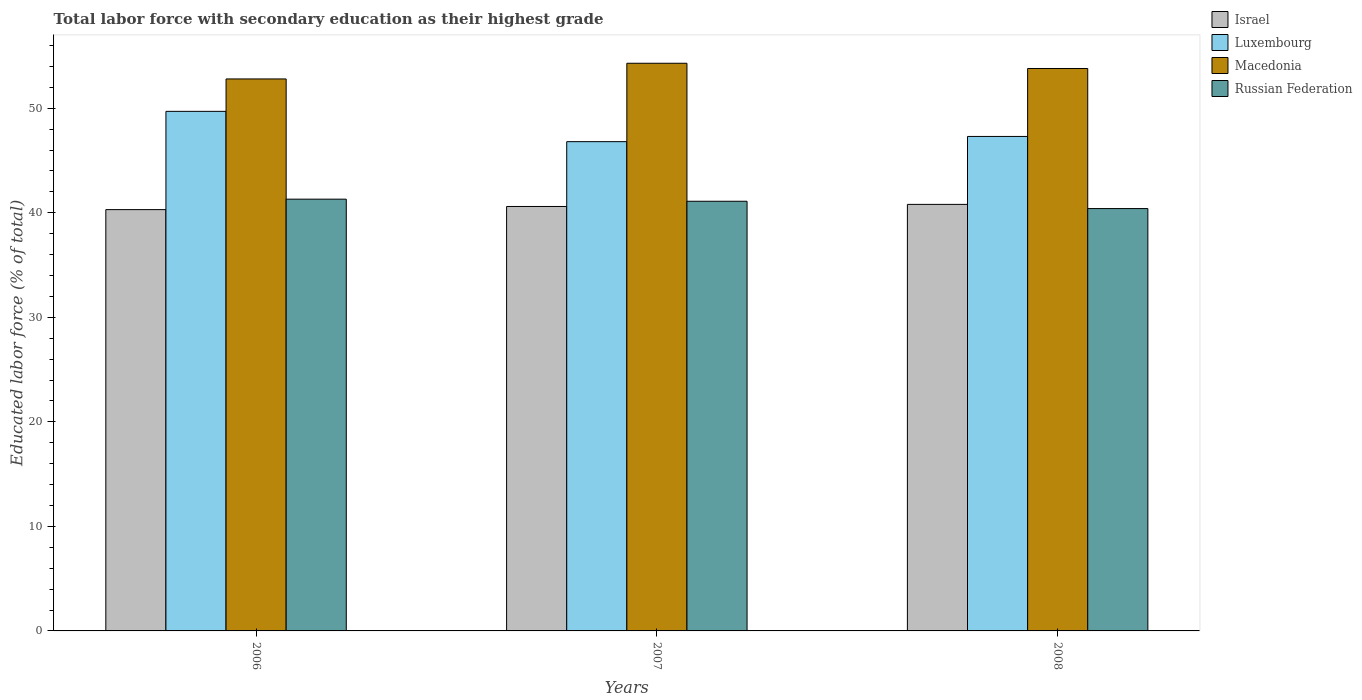Are the number of bars per tick equal to the number of legend labels?
Your response must be concise. Yes. Are the number of bars on each tick of the X-axis equal?
Offer a very short reply. Yes. How many bars are there on the 2nd tick from the left?
Your answer should be very brief. 4. How many bars are there on the 3rd tick from the right?
Your response must be concise. 4. What is the percentage of total labor force with primary education in Macedonia in 2006?
Keep it short and to the point. 52.8. Across all years, what is the maximum percentage of total labor force with primary education in Israel?
Offer a very short reply. 40.8. Across all years, what is the minimum percentage of total labor force with primary education in Luxembourg?
Your answer should be compact. 46.8. In which year was the percentage of total labor force with primary education in Luxembourg maximum?
Offer a terse response. 2006. What is the total percentage of total labor force with primary education in Israel in the graph?
Offer a terse response. 121.7. What is the average percentage of total labor force with primary education in Israel per year?
Your response must be concise. 40.57. In the year 2006, what is the difference between the percentage of total labor force with primary education in Macedonia and percentage of total labor force with primary education in Luxembourg?
Make the answer very short. 3.1. In how many years, is the percentage of total labor force with primary education in Israel greater than 44 %?
Give a very brief answer. 0. What is the ratio of the percentage of total labor force with primary education in Russian Federation in 2007 to that in 2008?
Offer a terse response. 1.02. What is the difference between the highest and the lowest percentage of total labor force with primary education in Israel?
Ensure brevity in your answer.  0.5. Is the sum of the percentage of total labor force with primary education in Macedonia in 2006 and 2007 greater than the maximum percentage of total labor force with primary education in Israel across all years?
Ensure brevity in your answer.  Yes. What does the 2nd bar from the left in 2006 represents?
Keep it short and to the point. Luxembourg. What does the 1st bar from the right in 2007 represents?
Provide a succinct answer. Russian Federation. Is it the case that in every year, the sum of the percentage of total labor force with primary education in Israel and percentage of total labor force with primary education in Macedonia is greater than the percentage of total labor force with primary education in Luxembourg?
Keep it short and to the point. Yes. How many bars are there?
Give a very brief answer. 12. Are all the bars in the graph horizontal?
Offer a very short reply. No. What is the difference between two consecutive major ticks on the Y-axis?
Your response must be concise. 10. Where does the legend appear in the graph?
Offer a terse response. Top right. How are the legend labels stacked?
Your response must be concise. Vertical. What is the title of the graph?
Offer a very short reply. Total labor force with secondary education as their highest grade. What is the label or title of the X-axis?
Your answer should be compact. Years. What is the label or title of the Y-axis?
Keep it short and to the point. Educated labor force (% of total). What is the Educated labor force (% of total) of Israel in 2006?
Make the answer very short. 40.3. What is the Educated labor force (% of total) of Luxembourg in 2006?
Keep it short and to the point. 49.7. What is the Educated labor force (% of total) of Macedonia in 2006?
Your answer should be very brief. 52.8. What is the Educated labor force (% of total) in Russian Federation in 2006?
Offer a terse response. 41.3. What is the Educated labor force (% of total) in Israel in 2007?
Keep it short and to the point. 40.6. What is the Educated labor force (% of total) in Luxembourg in 2007?
Your response must be concise. 46.8. What is the Educated labor force (% of total) in Macedonia in 2007?
Provide a short and direct response. 54.3. What is the Educated labor force (% of total) in Russian Federation in 2007?
Offer a terse response. 41.1. What is the Educated labor force (% of total) in Israel in 2008?
Offer a terse response. 40.8. What is the Educated labor force (% of total) of Luxembourg in 2008?
Ensure brevity in your answer.  47.3. What is the Educated labor force (% of total) in Macedonia in 2008?
Your response must be concise. 53.8. What is the Educated labor force (% of total) in Russian Federation in 2008?
Offer a terse response. 40.4. Across all years, what is the maximum Educated labor force (% of total) of Israel?
Give a very brief answer. 40.8. Across all years, what is the maximum Educated labor force (% of total) in Luxembourg?
Provide a short and direct response. 49.7. Across all years, what is the maximum Educated labor force (% of total) in Macedonia?
Your answer should be very brief. 54.3. Across all years, what is the maximum Educated labor force (% of total) in Russian Federation?
Offer a very short reply. 41.3. Across all years, what is the minimum Educated labor force (% of total) in Israel?
Keep it short and to the point. 40.3. Across all years, what is the minimum Educated labor force (% of total) in Luxembourg?
Your answer should be very brief. 46.8. Across all years, what is the minimum Educated labor force (% of total) of Macedonia?
Give a very brief answer. 52.8. Across all years, what is the minimum Educated labor force (% of total) of Russian Federation?
Your answer should be compact. 40.4. What is the total Educated labor force (% of total) in Israel in the graph?
Ensure brevity in your answer.  121.7. What is the total Educated labor force (% of total) in Luxembourg in the graph?
Keep it short and to the point. 143.8. What is the total Educated labor force (% of total) of Macedonia in the graph?
Provide a succinct answer. 160.9. What is the total Educated labor force (% of total) of Russian Federation in the graph?
Offer a terse response. 122.8. What is the difference between the Educated labor force (% of total) of Israel in 2006 and that in 2007?
Provide a short and direct response. -0.3. What is the difference between the Educated labor force (% of total) of Russian Federation in 2006 and that in 2007?
Your answer should be very brief. 0.2. What is the difference between the Educated labor force (% of total) of Israel in 2006 and that in 2008?
Ensure brevity in your answer.  -0.5. What is the difference between the Educated labor force (% of total) of Luxembourg in 2006 and that in 2008?
Offer a terse response. 2.4. What is the difference between the Educated labor force (% of total) of Israel in 2007 and that in 2008?
Your answer should be compact. -0.2. What is the difference between the Educated labor force (% of total) of Luxembourg in 2007 and that in 2008?
Your answer should be compact. -0.5. What is the difference between the Educated labor force (% of total) of Macedonia in 2007 and that in 2008?
Keep it short and to the point. 0.5. What is the difference between the Educated labor force (% of total) of Russian Federation in 2007 and that in 2008?
Keep it short and to the point. 0.7. What is the difference between the Educated labor force (% of total) in Israel in 2006 and the Educated labor force (% of total) in Luxembourg in 2007?
Ensure brevity in your answer.  -6.5. What is the difference between the Educated labor force (% of total) in Israel in 2006 and the Educated labor force (% of total) in Macedonia in 2007?
Your response must be concise. -14. What is the difference between the Educated labor force (% of total) of Israel in 2006 and the Educated labor force (% of total) of Russian Federation in 2007?
Provide a succinct answer. -0.8. What is the difference between the Educated labor force (% of total) in Luxembourg in 2006 and the Educated labor force (% of total) in Macedonia in 2007?
Provide a succinct answer. -4.6. What is the difference between the Educated labor force (% of total) of Macedonia in 2006 and the Educated labor force (% of total) of Russian Federation in 2007?
Your answer should be very brief. 11.7. What is the difference between the Educated labor force (% of total) of Israel in 2006 and the Educated labor force (% of total) of Russian Federation in 2008?
Ensure brevity in your answer.  -0.1. What is the difference between the Educated labor force (% of total) in Luxembourg in 2006 and the Educated labor force (% of total) in Macedonia in 2008?
Your answer should be very brief. -4.1. What is the difference between the Educated labor force (% of total) in Luxembourg in 2006 and the Educated labor force (% of total) in Russian Federation in 2008?
Provide a succinct answer. 9.3. What is the difference between the Educated labor force (% of total) of Macedonia in 2006 and the Educated labor force (% of total) of Russian Federation in 2008?
Offer a terse response. 12.4. What is the difference between the Educated labor force (% of total) in Israel in 2007 and the Educated labor force (% of total) in Russian Federation in 2008?
Make the answer very short. 0.2. What is the difference between the Educated labor force (% of total) in Luxembourg in 2007 and the Educated labor force (% of total) in Macedonia in 2008?
Make the answer very short. -7. What is the difference between the Educated labor force (% of total) in Macedonia in 2007 and the Educated labor force (% of total) in Russian Federation in 2008?
Offer a very short reply. 13.9. What is the average Educated labor force (% of total) of Israel per year?
Give a very brief answer. 40.57. What is the average Educated labor force (% of total) in Luxembourg per year?
Give a very brief answer. 47.93. What is the average Educated labor force (% of total) of Macedonia per year?
Offer a terse response. 53.63. What is the average Educated labor force (% of total) of Russian Federation per year?
Offer a terse response. 40.93. In the year 2006, what is the difference between the Educated labor force (% of total) in Israel and Educated labor force (% of total) in Luxembourg?
Your answer should be compact. -9.4. In the year 2006, what is the difference between the Educated labor force (% of total) of Israel and Educated labor force (% of total) of Macedonia?
Offer a very short reply. -12.5. In the year 2006, what is the difference between the Educated labor force (% of total) in Israel and Educated labor force (% of total) in Russian Federation?
Your answer should be very brief. -1. In the year 2006, what is the difference between the Educated labor force (% of total) of Luxembourg and Educated labor force (% of total) of Macedonia?
Provide a succinct answer. -3.1. In the year 2006, what is the difference between the Educated labor force (% of total) of Luxembourg and Educated labor force (% of total) of Russian Federation?
Offer a very short reply. 8.4. In the year 2006, what is the difference between the Educated labor force (% of total) in Macedonia and Educated labor force (% of total) in Russian Federation?
Give a very brief answer. 11.5. In the year 2007, what is the difference between the Educated labor force (% of total) in Israel and Educated labor force (% of total) in Luxembourg?
Your answer should be very brief. -6.2. In the year 2007, what is the difference between the Educated labor force (% of total) in Israel and Educated labor force (% of total) in Macedonia?
Offer a terse response. -13.7. In the year 2007, what is the difference between the Educated labor force (% of total) in Luxembourg and Educated labor force (% of total) in Macedonia?
Keep it short and to the point. -7.5. In the year 2007, what is the difference between the Educated labor force (% of total) of Luxembourg and Educated labor force (% of total) of Russian Federation?
Provide a succinct answer. 5.7. In the year 2007, what is the difference between the Educated labor force (% of total) in Macedonia and Educated labor force (% of total) in Russian Federation?
Make the answer very short. 13.2. In the year 2008, what is the difference between the Educated labor force (% of total) of Israel and Educated labor force (% of total) of Luxembourg?
Your response must be concise. -6.5. What is the ratio of the Educated labor force (% of total) in Luxembourg in 2006 to that in 2007?
Your answer should be compact. 1.06. What is the ratio of the Educated labor force (% of total) of Macedonia in 2006 to that in 2007?
Provide a succinct answer. 0.97. What is the ratio of the Educated labor force (% of total) of Russian Federation in 2006 to that in 2007?
Make the answer very short. 1. What is the ratio of the Educated labor force (% of total) in Israel in 2006 to that in 2008?
Provide a succinct answer. 0.99. What is the ratio of the Educated labor force (% of total) in Luxembourg in 2006 to that in 2008?
Ensure brevity in your answer.  1.05. What is the ratio of the Educated labor force (% of total) of Macedonia in 2006 to that in 2008?
Provide a short and direct response. 0.98. What is the ratio of the Educated labor force (% of total) of Russian Federation in 2006 to that in 2008?
Your answer should be very brief. 1.02. What is the ratio of the Educated labor force (% of total) in Luxembourg in 2007 to that in 2008?
Keep it short and to the point. 0.99. What is the ratio of the Educated labor force (% of total) in Macedonia in 2007 to that in 2008?
Your answer should be very brief. 1.01. What is the ratio of the Educated labor force (% of total) of Russian Federation in 2007 to that in 2008?
Provide a succinct answer. 1.02. What is the difference between the highest and the second highest Educated labor force (% of total) of Luxembourg?
Offer a terse response. 2.4. What is the difference between the highest and the second highest Educated labor force (% of total) of Macedonia?
Provide a short and direct response. 0.5. What is the difference between the highest and the second highest Educated labor force (% of total) of Russian Federation?
Your answer should be compact. 0.2. 